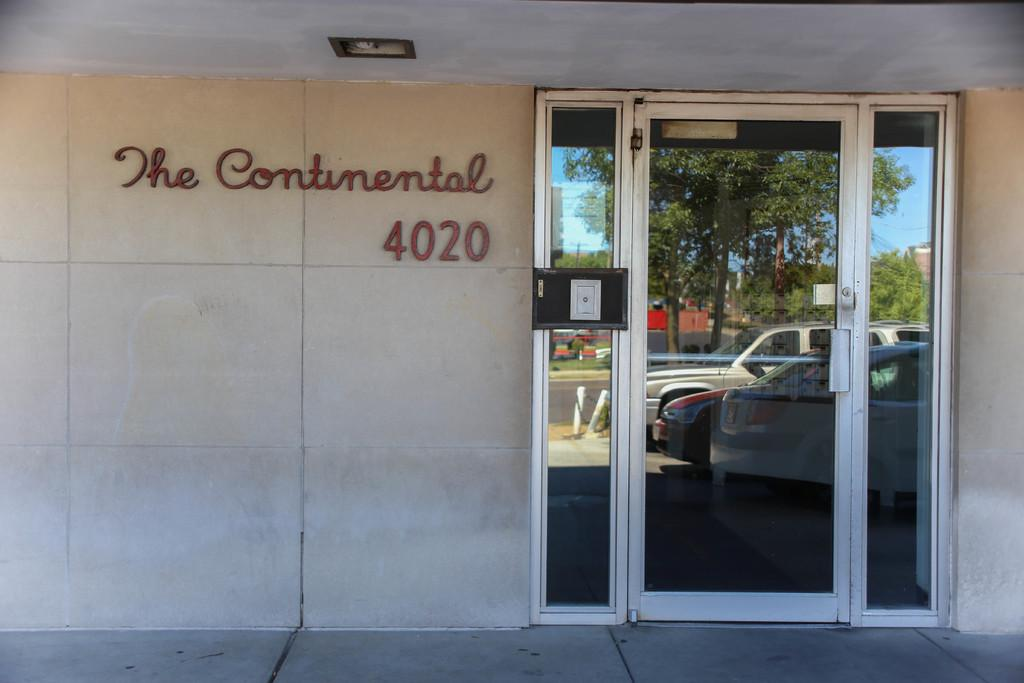What type of structure can be seen in the image? There is a wall in the image. Is there any entrance or exit visible in the image? Yes, there is a glass door in the image. What can be seen in the reflection of the glass door? The reflection of the glass door shows cars, trees, and the sky. What is written or displayed on the wall? There is text on the wall. Are there any cattle visible in the image? No, there are no cattle present in the image. What type of tent can be seen in the image? There is no tent present in the image. 